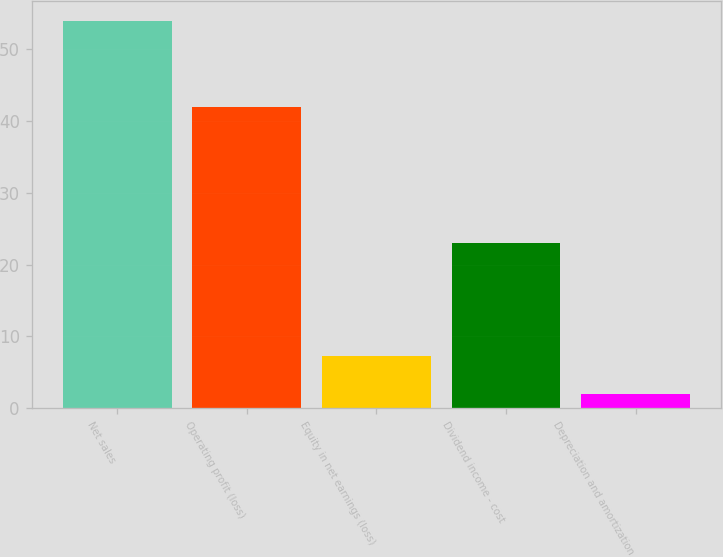<chart> <loc_0><loc_0><loc_500><loc_500><bar_chart><fcel>Net sales<fcel>Operating profit (loss)<fcel>Equity in net earnings (loss)<fcel>Dividend income - cost<fcel>Depreciation and amortization<nl><fcel>54<fcel>42<fcel>7.2<fcel>23<fcel>2<nl></chart> 